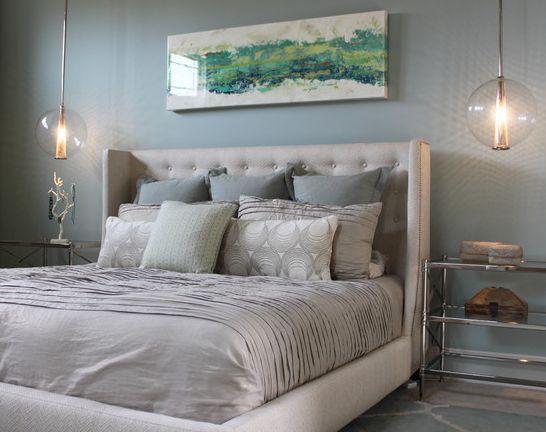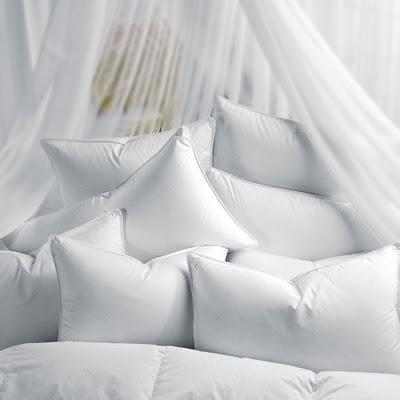The first image is the image on the left, the second image is the image on the right. For the images displayed, is the sentence "Rumpled sheets and pillows of an unmade bed are shown in one image." factually correct? Answer yes or no. No. 